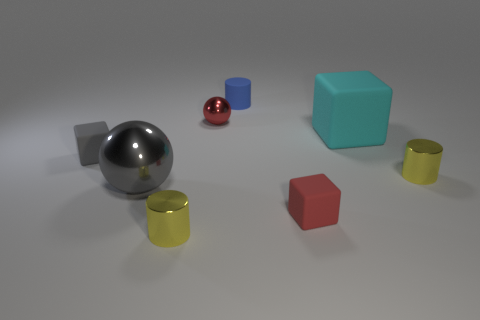How many large things have the same material as the big cyan block?
Your answer should be compact. 0. There is a metal cylinder to the right of the cyan matte block; is it the same size as the gray ball?
Keep it short and to the point. No. The small cylinder that is made of the same material as the large cyan object is what color?
Ensure brevity in your answer.  Blue. Are there any other things that have the same size as the matte cylinder?
Your answer should be compact. Yes. There is a cyan matte thing; what number of metallic spheres are behind it?
Provide a short and direct response. 1. Is the color of the large rubber thing that is on the right side of the big gray shiny object the same as the small matte cube that is on the left side of the red matte block?
Make the answer very short. No. What color is the other object that is the same shape as the large metal object?
Your response must be concise. Red. Is there any other thing that is the same shape as the large metallic object?
Provide a short and direct response. Yes. There is a rubber thing behind the cyan object; is its shape the same as the small metallic thing right of the blue thing?
Offer a very short reply. Yes. Does the gray shiny ball have the same size as the cube that is right of the red matte block?
Your response must be concise. Yes. 